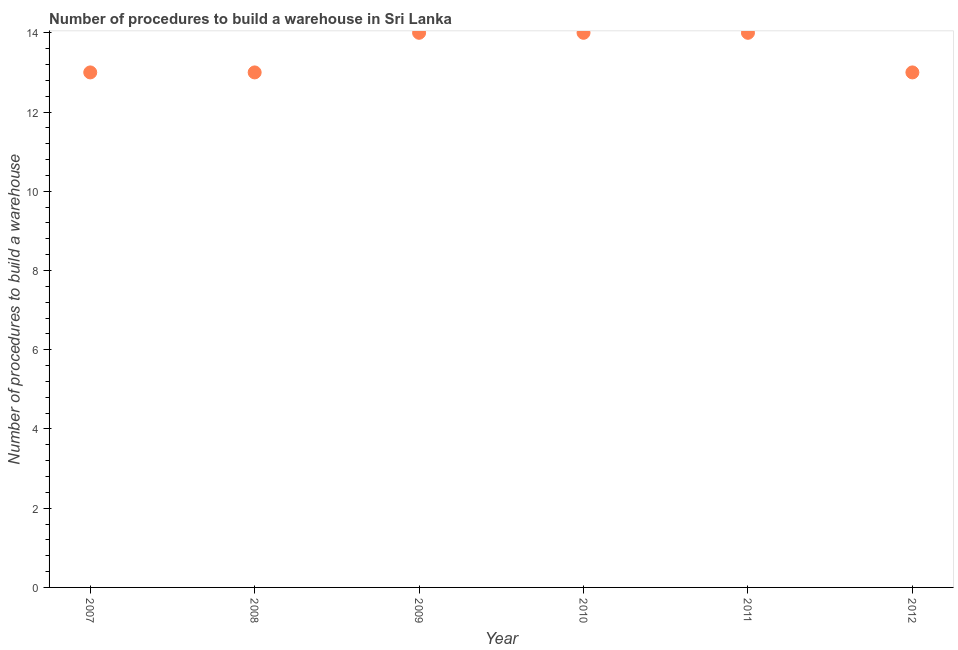What is the number of procedures to build a warehouse in 2011?
Your answer should be compact. 14. Across all years, what is the maximum number of procedures to build a warehouse?
Ensure brevity in your answer.  14. Across all years, what is the minimum number of procedures to build a warehouse?
Your answer should be very brief. 13. In which year was the number of procedures to build a warehouse maximum?
Your answer should be compact. 2009. What is the sum of the number of procedures to build a warehouse?
Make the answer very short. 81. What is the difference between the number of procedures to build a warehouse in 2009 and 2012?
Offer a very short reply. 1. What is the average number of procedures to build a warehouse per year?
Keep it short and to the point. 13.5. What is the median number of procedures to build a warehouse?
Offer a very short reply. 13.5. In how many years, is the number of procedures to build a warehouse greater than 6.4 ?
Your answer should be compact. 6. Do a majority of the years between 2007 and 2011 (inclusive) have number of procedures to build a warehouse greater than 9.2 ?
Your response must be concise. Yes. What is the ratio of the number of procedures to build a warehouse in 2007 to that in 2011?
Ensure brevity in your answer.  0.93. Is the difference between the number of procedures to build a warehouse in 2007 and 2009 greater than the difference between any two years?
Provide a short and direct response. Yes. What is the difference between the highest and the second highest number of procedures to build a warehouse?
Offer a terse response. 0. Is the sum of the number of procedures to build a warehouse in 2007 and 2011 greater than the maximum number of procedures to build a warehouse across all years?
Your answer should be compact. Yes. What is the difference between the highest and the lowest number of procedures to build a warehouse?
Keep it short and to the point. 1. Does the number of procedures to build a warehouse monotonically increase over the years?
Your answer should be compact. No. How many dotlines are there?
Your response must be concise. 1. Does the graph contain grids?
Offer a terse response. No. What is the title of the graph?
Offer a very short reply. Number of procedures to build a warehouse in Sri Lanka. What is the label or title of the Y-axis?
Offer a very short reply. Number of procedures to build a warehouse. What is the Number of procedures to build a warehouse in 2007?
Give a very brief answer. 13. What is the Number of procedures to build a warehouse in 2009?
Offer a terse response. 14. What is the Number of procedures to build a warehouse in 2010?
Provide a short and direct response. 14. What is the difference between the Number of procedures to build a warehouse in 2007 and 2008?
Your answer should be compact. 0. What is the difference between the Number of procedures to build a warehouse in 2007 and 2009?
Make the answer very short. -1. What is the difference between the Number of procedures to build a warehouse in 2007 and 2012?
Offer a very short reply. 0. What is the difference between the Number of procedures to build a warehouse in 2008 and 2009?
Your answer should be very brief. -1. What is the difference between the Number of procedures to build a warehouse in 2009 and 2010?
Give a very brief answer. 0. What is the difference between the Number of procedures to build a warehouse in 2009 and 2011?
Your answer should be very brief. 0. What is the difference between the Number of procedures to build a warehouse in 2010 and 2012?
Offer a very short reply. 1. What is the ratio of the Number of procedures to build a warehouse in 2007 to that in 2009?
Offer a terse response. 0.93. What is the ratio of the Number of procedures to build a warehouse in 2007 to that in 2010?
Ensure brevity in your answer.  0.93. What is the ratio of the Number of procedures to build a warehouse in 2007 to that in 2011?
Offer a very short reply. 0.93. What is the ratio of the Number of procedures to build a warehouse in 2007 to that in 2012?
Give a very brief answer. 1. What is the ratio of the Number of procedures to build a warehouse in 2008 to that in 2009?
Ensure brevity in your answer.  0.93. What is the ratio of the Number of procedures to build a warehouse in 2008 to that in 2010?
Provide a succinct answer. 0.93. What is the ratio of the Number of procedures to build a warehouse in 2008 to that in 2011?
Offer a very short reply. 0.93. What is the ratio of the Number of procedures to build a warehouse in 2008 to that in 2012?
Ensure brevity in your answer.  1. What is the ratio of the Number of procedures to build a warehouse in 2009 to that in 2010?
Offer a very short reply. 1. What is the ratio of the Number of procedures to build a warehouse in 2009 to that in 2011?
Ensure brevity in your answer.  1. What is the ratio of the Number of procedures to build a warehouse in 2009 to that in 2012?
Make the answer very short. 1.08. What is the ratio of the Number of procedures to build a warehouse in 2010 to that in 2011?
Your answer should be compact. 1. What is the ratio of the Number of procedures to build a warehouse in 2010 to that in 2012?
Make the answer very short. 1.08. What is the ratio of the Number of procedures to build a warehouse in 2011 to that in 2012?
Ensure brevity in your answer.  1.08. 